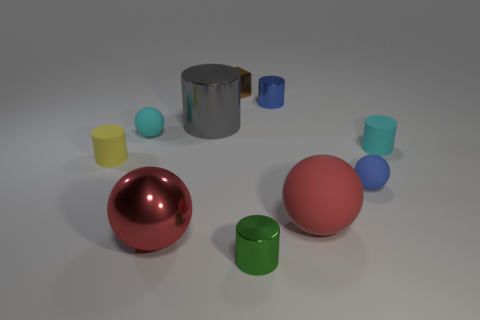Can you tell me the total count of objects present in the image? There are a total of eight objects in the image, comprising a mixture of spheres, cylinders, and a cube. 